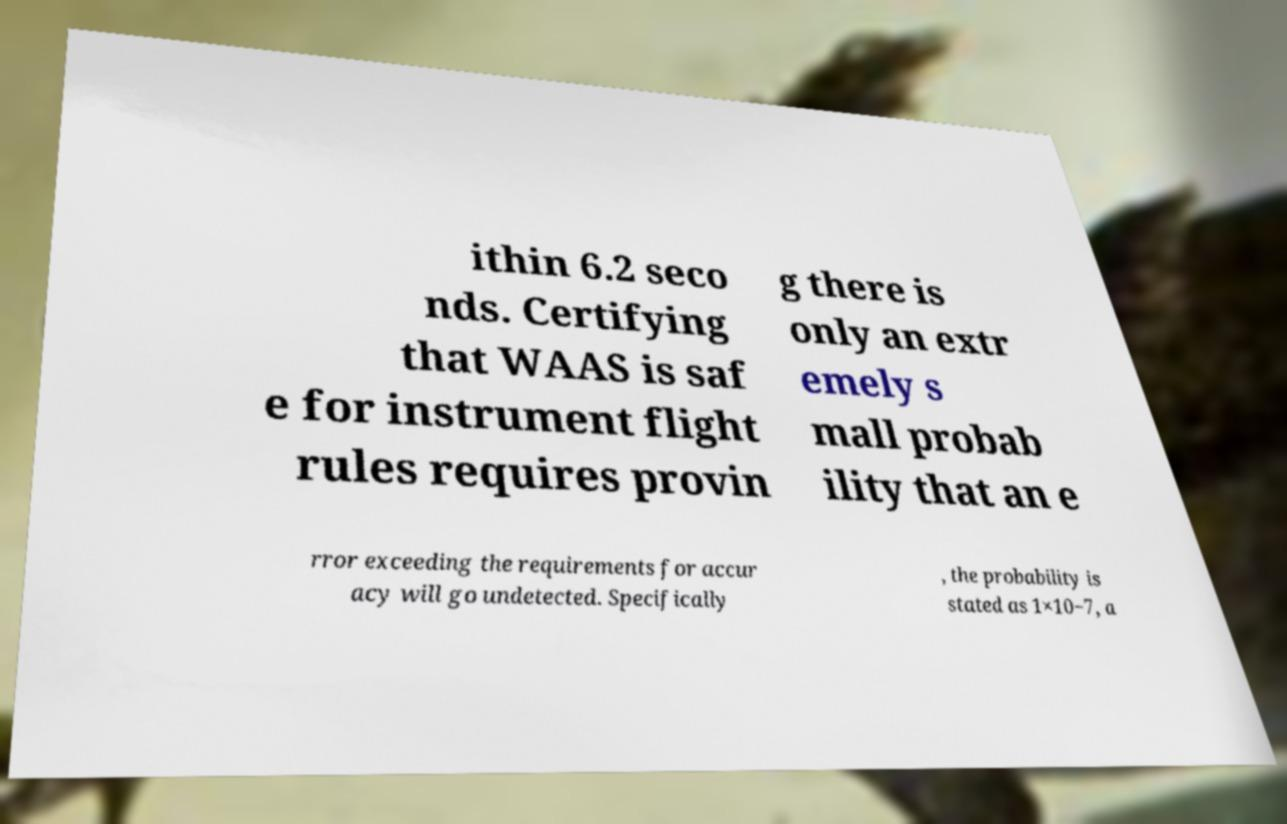Please identify and transcribe the text found in this image. ithin 6.2 seco nds. Certifying that WAAS is saf e for instrument flight rules requires provin g there is only an extr emely s mall probab ility that an e rror exceeding the requirements for accur acy will go undetected. Specifically , the probability is stated as 1×10−7, a 